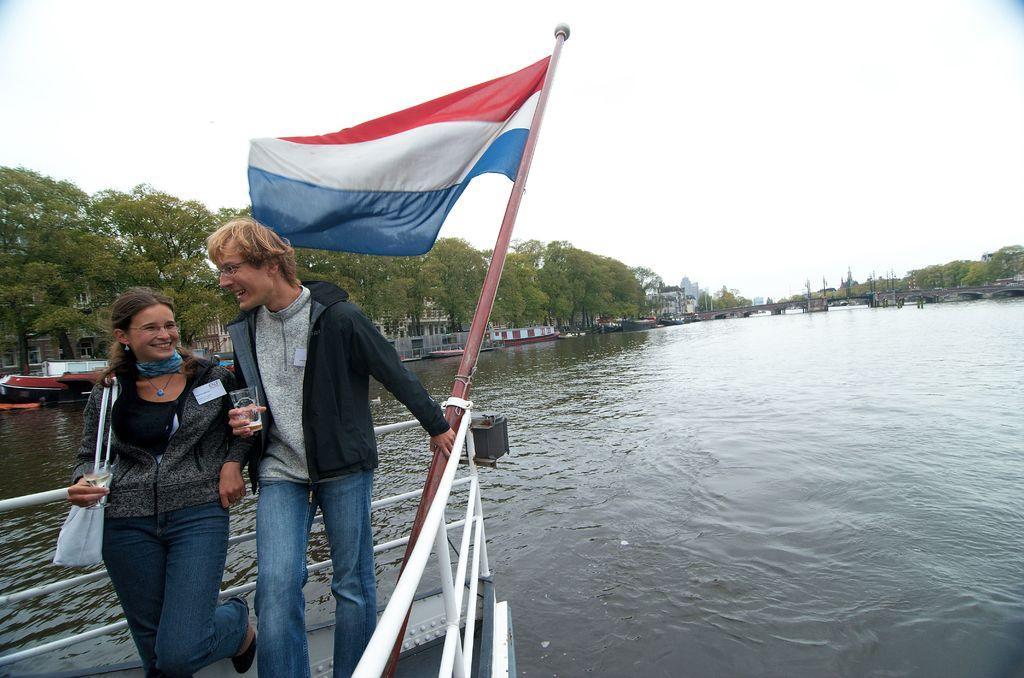Describe this image in one or two sentences. In this image it seems like a ship, which is on the river, there is a couple standing and smiling. In the background there are buildings and trees. 